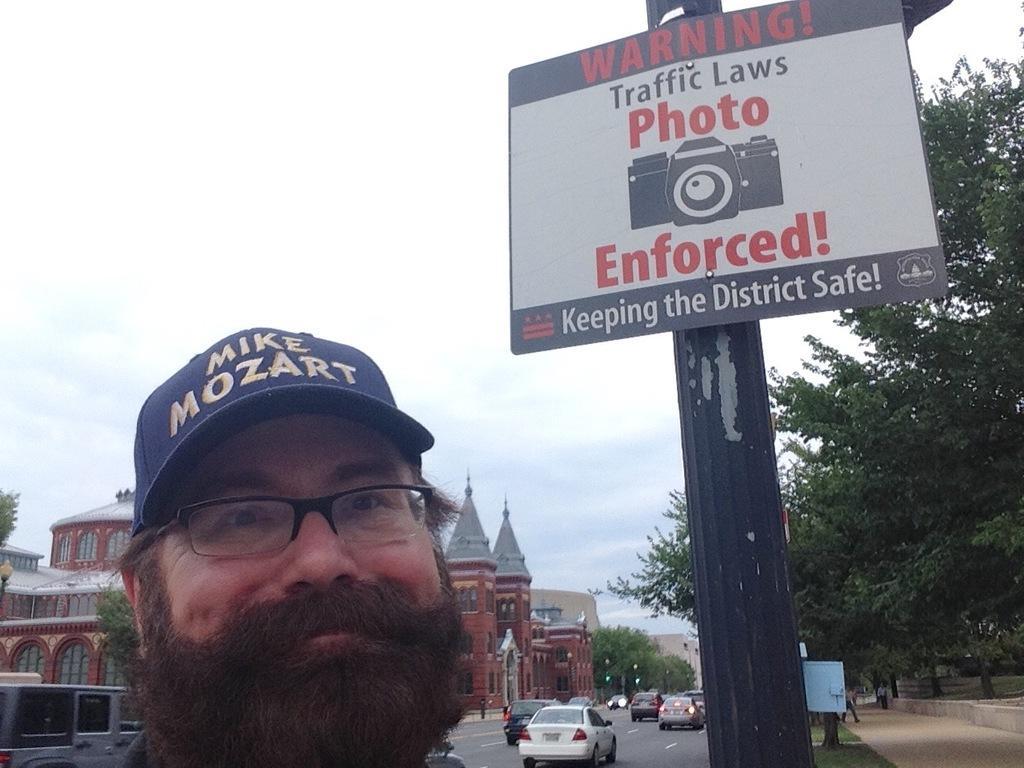Can you describe this image briefly? In the background we can see the sky, buildings. In this picture we can see the people, vehicles on the road. We can see a sign board, trees, pole and few objects. This picture is mainly highlighted with a man wearing a cap, spectacles. 